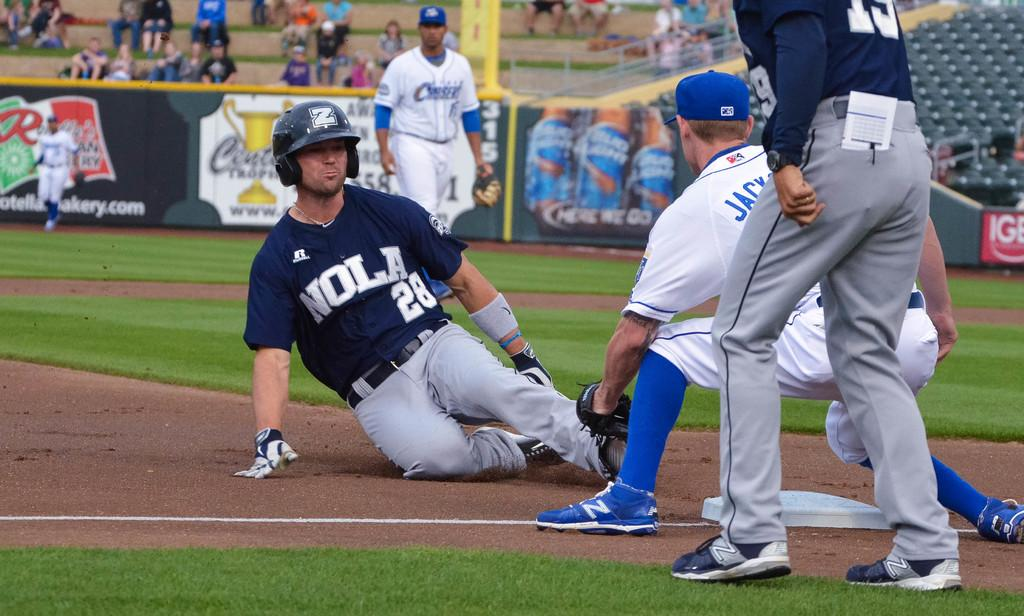<image>
Relay a brief, clear account of the picture shown. A Nola baseball player sliding into third base 